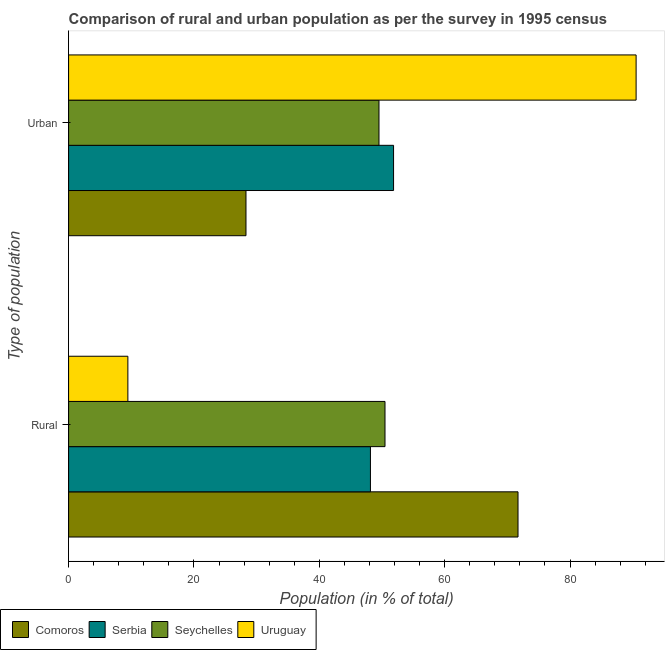How many different coloured bars are there?
Ensure brevity in your answer.  4. How many groups of bars are there?
Give a very brief answer. 2. Are the number of bars on each tick of the Y-axis equal?
Your answer should be very brief. Yes. How many bars are there on the 2nd tick from the top?
Your answer should be very brief. 4. What is the label of the 2nd group of bars from the top?
Provide a succinct answer. Rural. What is the urban population in Uruguay?
Your answer should be compact. 90.54. Across all countries, what is the maximum rural population?
Your answer should be very brief. 71.7. Across all countries, what is the minimum rural population?
Provide a short and direct response. 9.46. In which country was the urban population maximum?
Offer a very short reply. Uruguay. In which country was the urban population minimum?
Ensure brevity in your answer.  Comoros. What is the total rural population in the graph?
Provide a succinct answer. 179.79. What is the difference between the urban population in Seychelles and that in Comoros?
Provide a succinct answer. 21.22. What is the difference between the urban population in Seychelles and the rural population in Comoros?
Provide a short and direct response. -22.18. What is the average urban population per country?
Give a very brief answer. 55.05. What is the difference between the urban population and rural population in Comoros?
Give a very brief answer. -43.4. In how many countries, is the urban population greater than 44 %?
Your answer should be very brief. 3. What is the ratio of the urban population in Uruguay to that in Seychelles?
Keep it short and to the point. 1.83. Is the rural population in Seychelles less than that in Uruguay?
Ensure brevity in your answer.  No. In how many countries, is the urban population greater than the average urban population taken over all countries?
Provide a succinct answer. 1. What does the 3rd bar from the top in Urban represents?
Ensure brevity in your answer.  Serbia. What does the 2nd bar from the bottom in Urban represents?
Keep it short and to the point. Serbia. How many bars are there?
Your answer should be compact. 8. Does the graph contain grids?
Offer a very short reply. No. Where does the legend appear in the graph?
Keep it short and to the point. Bottom left. How many legend labels are there?
Provide a short and direct response. 4. What is the title of the graph?
Keep it short and to the point. Comparison of rural and urban population as per the survey in 1995 census. Does "East Asia (developing only)" appear as one of the legend labels in the graph?
Make the answer very short. No. What is the label or title of the X-axis?
Offer a very short reply. Population (in % of total). What is the label or title of the Y-axis?
Give a very brief answer. Type of population. What is the Population (in % of total) of Comoros in Rural?
Your response must be concise. 71.7. What is the Population (in % of total) of Serbia in Rural?
Provide a succinct answer. 48.16. What is the Population (in % of total) in Seychelles in Rural?
Provide a succinct answer. 50.48. What is the Population (in % of total) in Uruguay in Rural?
Your answer should be compact. 9.46. What is the Population (in % of total) of Comoros in Urban?
Keep it short and to the point. 28.3. What is the Population (in % of total) of Serbia in Urban?
Make the answer very short. 51.84. What is the Population (in % of total) of Seychelles in Urban?
Your answer should be very brief. 49.52. What is the Population (in % of total) in Uruguay in Urban?
Keep it short and to the point. 90.54. Across all Type of population, what is the maximum Population (in % of total) in Comoros?
Provide a short and direct response. 71.7. Across all Type of population, what is the maximum Population (in % of total) of Serbia?
Offer a terse response. 51.84. Across all Type of population, what is the maximum Population (in % of total) in Seychelles?
Your response must be concise. 50.48. Across all Type of population, what is the maximum Population (in % of total) of Uruguay?
Provide a succinct answer. 90.54. Across all Type of population, what is the minimum Population (in % of total) of Comoros?
Make the answer very short. 28.3. Across all Type of population, what is the minimum Population (in % of total) of Serbia?
Provide a short and direct response. 48.16. Across all Type of population, what is the minimum Population (in % of total) in Seychelles?
Your answer should be compact. 49.52. Across all Type of population, what is the minimum Population (in % of total) in Uruguay?
Give a very brief answer. 9.46. What is the total Population (in % of total) in Seychelles in the graph?
Provide a succinct answer. 100. What is the difference between the Population (in % of total) in Comoros in Rural and that in Urban?
Provide a succinct answer. 43.4. What is the difference between the Population (in % of total) of Serbia in Rural and that in Urban?
Provide a short and direct response. -3.69. What is the difference between the Population (in % of total) of Uruguay in Rural and that in Urban?
Your answer should be very brief. -81.08. What is the difference between the Population (in % of total) of Comoros in Rural and the Population (in % of total) of Serbia in Urban?
Give a very brief answer. 19.86. What is the difference between the Population (in % of total) in Comoros in Rural and the Population (in % of total) in Seychelles in Urban?
Make the answer very short. 22.18. What is the difference between the Population (in % of total) in Comoros in Rural and the Population (in % of total) in Uruguay in Urban?
Give a very brief answer. -18.84. What is the difference between the Population (in % of total) in Serbia in Rural and the Population (in % of total) in Seychelles in Urban?
Provide a short and direct response. -1.36. What is the difference between the Population (in % of total) in Serbia in Rural and the Population (in % of total) in Uruguay in Urban?
Your answer should be compact. -42.39. What is the difference between the Population (in % of total) of Seychelles in Rural and the Population (in % of total) of Uruguay in Urban?
Your answer should be very brief. -40.06. What is the average Population (in % of total) in Comoros per Type of population?
Offer a very short reply. 50. What is the average Population (in % of total) of Serbia per Type of population?
Your answer should be compact. 50. What is the difference between the Population (in % of total) in Comoros and Population (in % of total) in Serbia in Rural?
Your answer should be very brief. 23.54. What is the difference between the Population (in % of total) of Comoros and Population (in % of total) of Seychelles in Rural?
Your answer should be very brief. 21.22. What is the difference between the Population (in % of total) of Comoros and Population (in % of total) of Uruguay in Rural?
Your answer should be very brief. 62.24. What is the difference between the Population (in % of total) in Serbia and Population (in % of total) in Seychelles in Rural?
Make the answer very short. -2.32. What is the difference between the Population (in % of total) of Serbia and Population (in % of total) of Uruguay in Rural?
Offer a very short reply. 38.7. What is the difference between the Population (in % of total) in Seychelles and Population (in % of total) in Uruguay in Rural?
Your answer should be compact. 41.02. What is the difference between the Population (in % of total) of Comoros and Population (in % of total) of Serbia in Urban?
Offer a very short reply. -23.54. What is the difference between the Population (in % of total) of Comoros and Population (in % of total) of Seychelles in Urban?
Ensure brevity in your answer.  -21.22. What is the difference between the Population (in % of total) of Comoros and Population (in % of total) of Uruguay in Urban?
Offer a terse response. -62.24. What is the difference between the Population (in % of total) of Serbia and Population (in % of total) of Seychelles in Urban?
Provide a short and direct response. 2.32. What is the difference between the Population (in % of total) of Serbia and Population (in % of total) of Uruguay in Urban?
Provide a short and direct response. -38.7. What is the difference between the Population (in % of total) of Seychelles and Population (in % of total) of Uruguay in Urban?
Your response must be concise. -41.02. What is the ratio of the Population (in % of total) of Comoros in Rural to that in Urban?
Provide a succinct answer. 2.53. What is the ratio of the Population (in % of total) in Serbia in Rural to that in Urban?
Make the answer very short. 0.93. What is the ratio of the Population (in % of total) in Seychelles in Rural to that in Urban?
Offer a terse response. 1.02. What is the ratio of the Population (in % of total) of Uruguay in Rural to that in Urban?
Provide a short and direct response. 0.1. What is the difference between the highest and the second highest Population (in % of total) in Comoros?
Offer a terse response. 43.4. What is the difference between the highest and the second highest Population (in % of total) of Serbia?
Provide a succinct answer. 3.69. What is the difference between the highest and the second highest Population (in % of total) of Seychelles?
Offer a terse response. 0.96. What is the difference between the highest and the second highest Population (in % of total) in Uruguay?
Give a very brief answer. 81.08. What is the difference between the highest and the lowest Population (in % of total) of Comoros?
Give a very brief answer. 43.4. What is the difference between the highest and the lowest Population (in % of total) in Serbia?
Provide a succinct answer. 3.69. What is the difference between the highest and the lowest Population (in % of total) in Uruguay?
Your answer should be very brief. 81.08. 